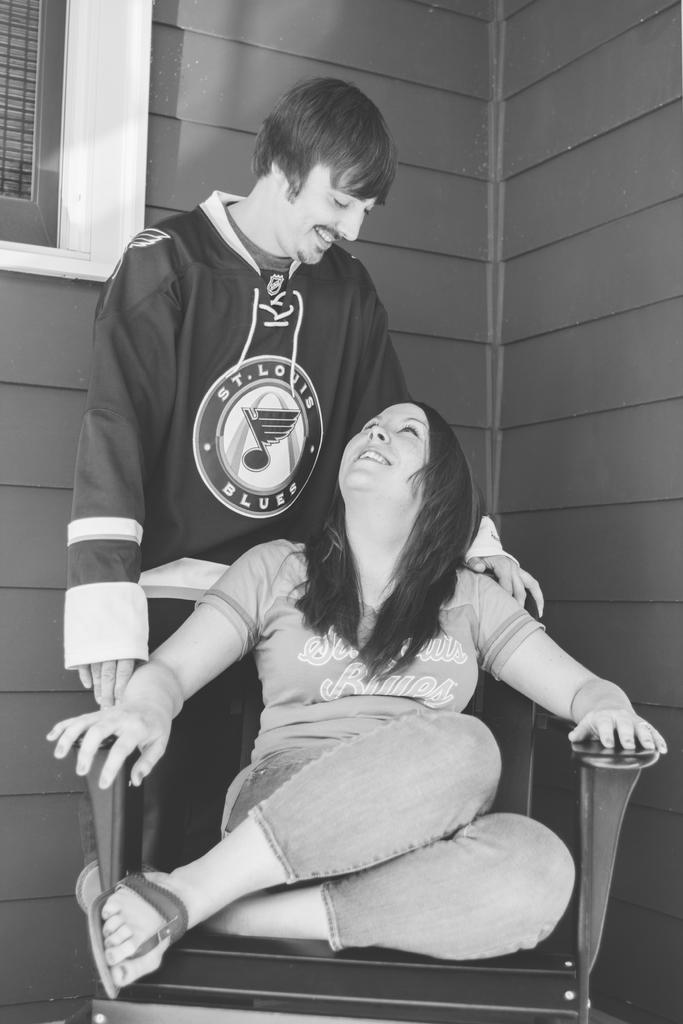<image>
Summarize the visual content of the image. A man wearing a St Louis Blues shirt looks down at a woman on a chair 